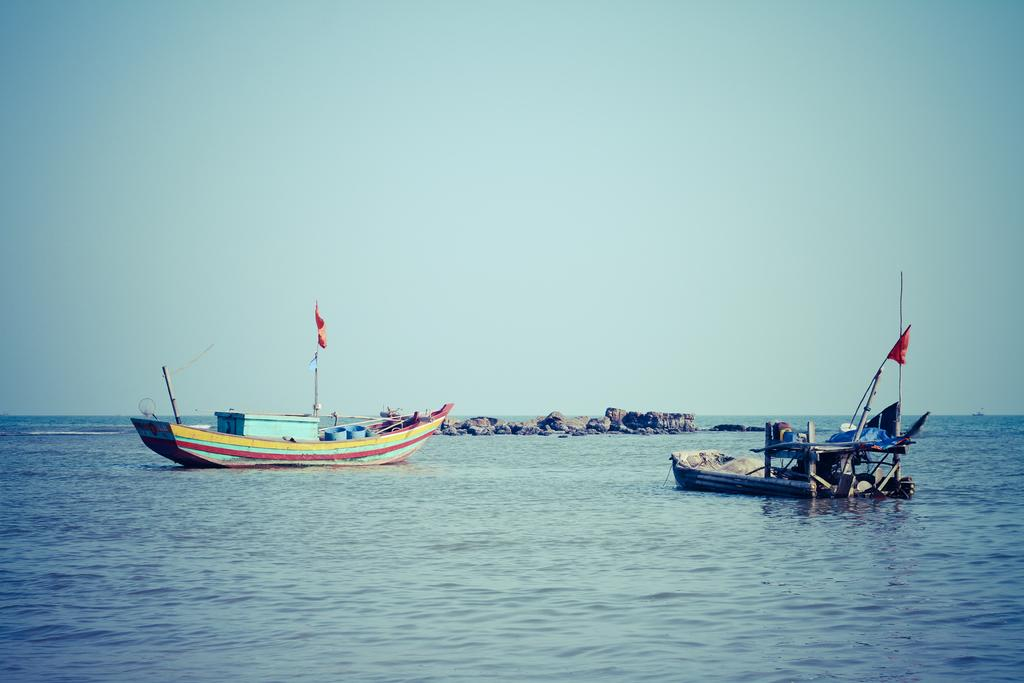What is at the bottom of the image? There is water at the bottom of the image. What can be seen floating on the water? There are two boats in the water. What else is present in the middle of the image? There are stones in the middle of the image. What type of square can be seen in the image? There is no square present in the image. Can you tell me how many cherries are floating in the water? There are no cherries present in the image; it features water, boats, and stones. 